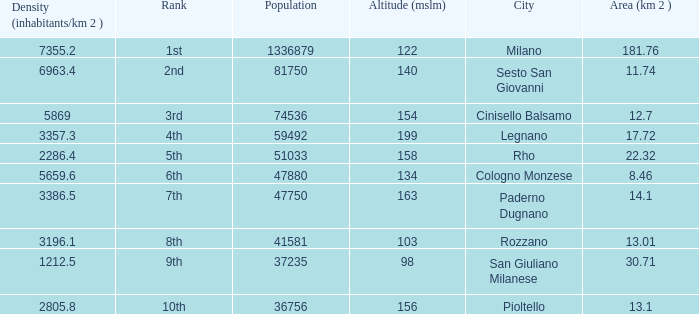Which Altitude (mslm) is the highest one that has a City of legnano, and a Population larger than 59492? None. 